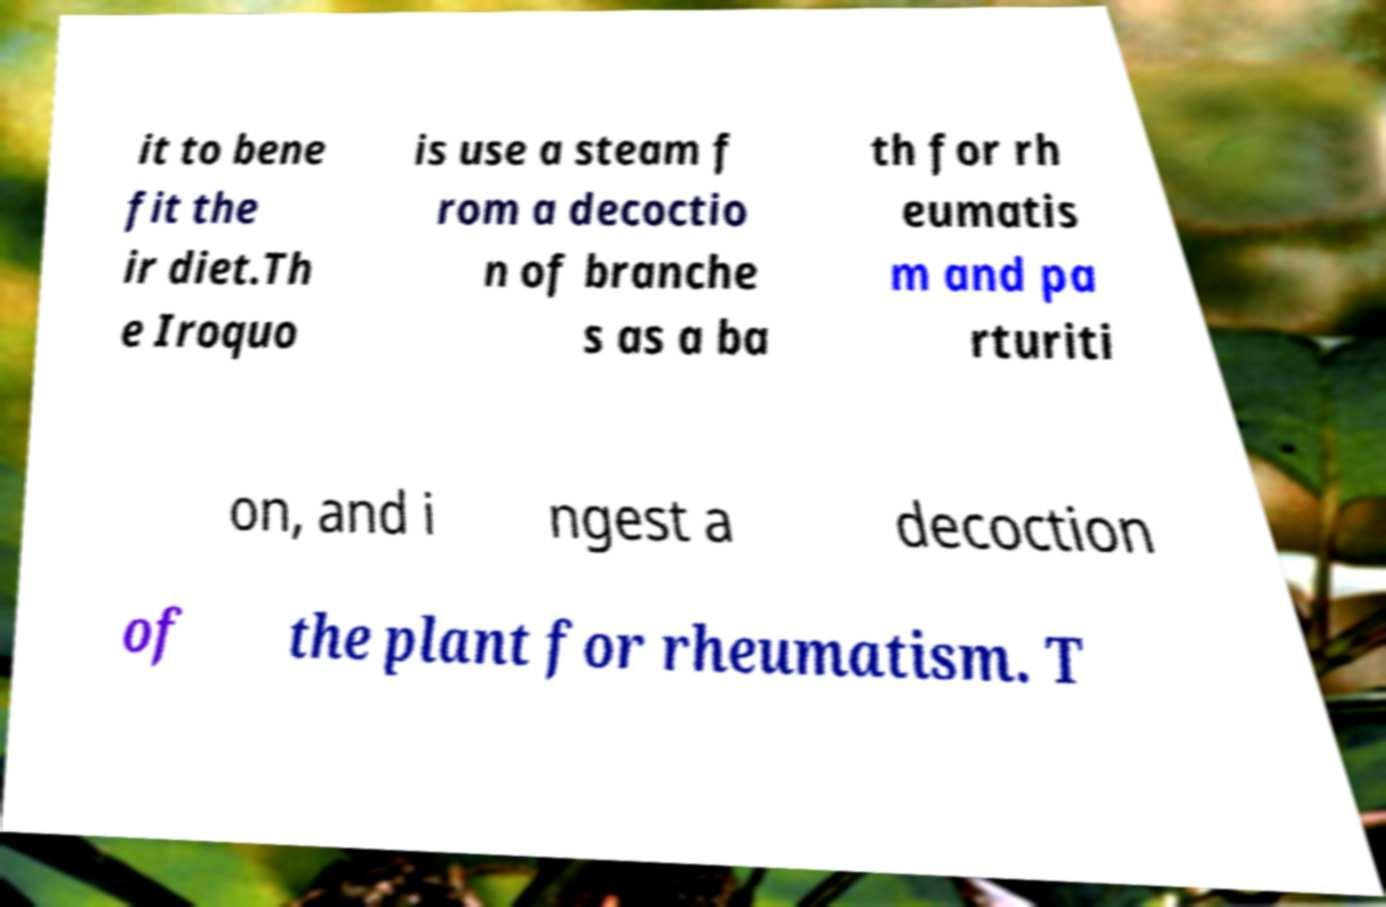There's text embedded in this image that I need extracted. Can you transcribe it verbatim? it to bene fit the ir diet.Th e Iroquo is use a steam f rom a decoctio n of branche s as a ba th for rh eumatis m and pa rturiti on, and i ngest a decoction of the plant for rheumatism. T 